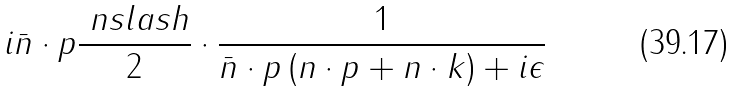Convert formula to latex. <formula><loc_0><loc_0><loc_500><loc_500>i \bar { n } \cdot p \frac { \ n s l a s h } { 2 } \cdot \frac { 1 } { \bar { n } \cdot p \, ( n \cdot p + n \cdot k ) + i \epsilon }</formula> 